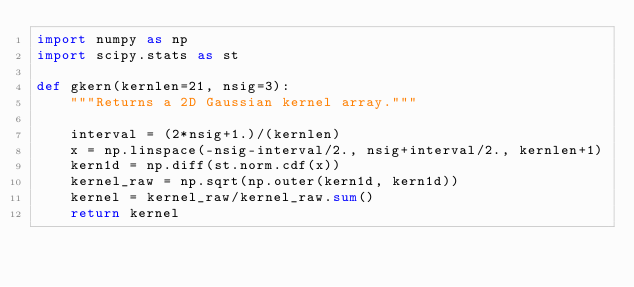<code> <loc_0><loc_0><loc_500><loc_500><_Python_>import numpy as np
import scipy.stats as st

def gkern(kernlen=21, nsig=3):
    """Returns a 2D Gaussian kernel array."""

    interval = (2*nsig+1.)/(kernlen)
    x = np.linspace(-nsig-interval/2., nsig+interval/2., kernlen+1)
    kern1d = np.diff(st.norm.cdf(x))
    kernel_raw = np.sqrt(np.outer(kern1d, kern1d))
    kernel = kernel_raw/kernel_raw.sum()
    return kernel
</code> 